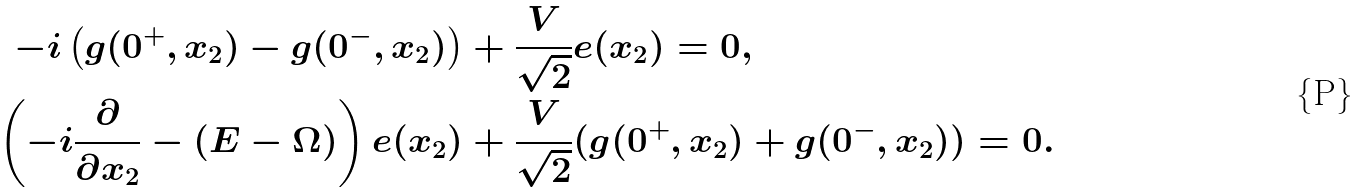Convert formula to latex. <formula><loc_0><loc_0><loc_500><loc_500>- i \left ( g ( 0 ^ { + } , x _ { 2 } ) - g ( 0 ^ { - } , x _ { 2 } ) \right ) & + \frac { V } { \sqrt { 2 } } e ( x _ { 2 } ) = 0 , \\ \left ( - i \frac { \partial } { \partial x _ { 2 } } - ( E - \Omega ) \right ) e ( x _ { 2 } ) & + \frac { V } { \sqrt { 2 } } ( g ( 0 ^ { + } , x _ { 2 } ) + g ( 0 ^ { - } , x _ { 2 } ) ) = 0 .</formula> 